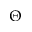<formula> <loc_0><loc_0><loc_500><loc_500>\Theta</formula> 